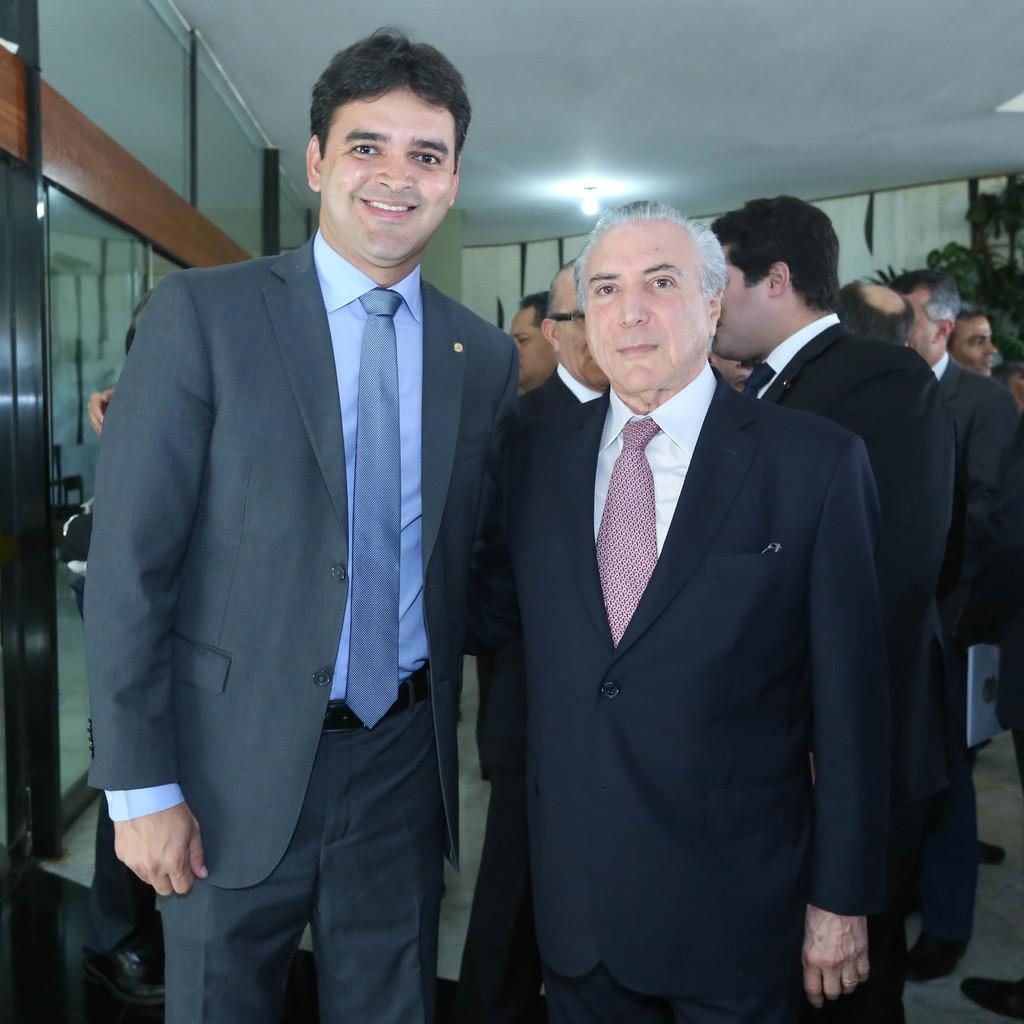How many people are in the image? There are two persons in the image. What are the two persons doing in the image? The two persons are standing. What expressions do the two persons have in the image? The two persons are smiling. In which direction are the two persons looking in the image? The two persons are looking at the front side. What type of door can be seen in the image? There is no door present in the image; it features two standing persons who are smiling and looking at the front side. What kind of pie is being served on a plate in the image? There is no pie present in the image. 